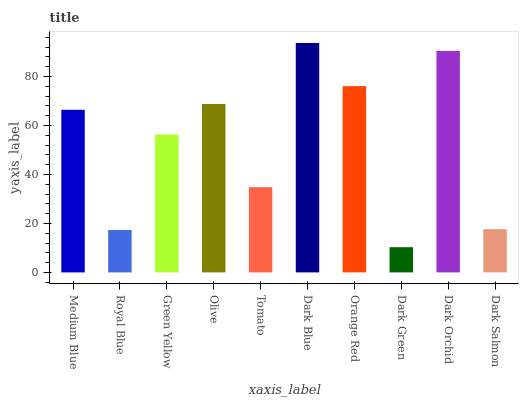Is Royal Blue the minimum?
Answer yes or no. No. Is Royal Blue the maximum?
Answer yes or no. No. Is Medium Blue greater than Royal Blue?
Answer yes or no. Yes. Is Royal Blue less than Medium Blue?
Answer yes or no. Yes. Is Royal Blue greater than Medium Blue?
Answer yes or no. No. Is Medium Blue less than Royal Blue?
Answer yes or no. No. Is Medium Blue the high median?
Answer yes or no. Yes. Is Green Yellow the low median?
Answer yes or no. Yes. Is Tomato the high median?
Answer yes or no. No. Is Dark Blue the low median?
Answer yes or no. No. 